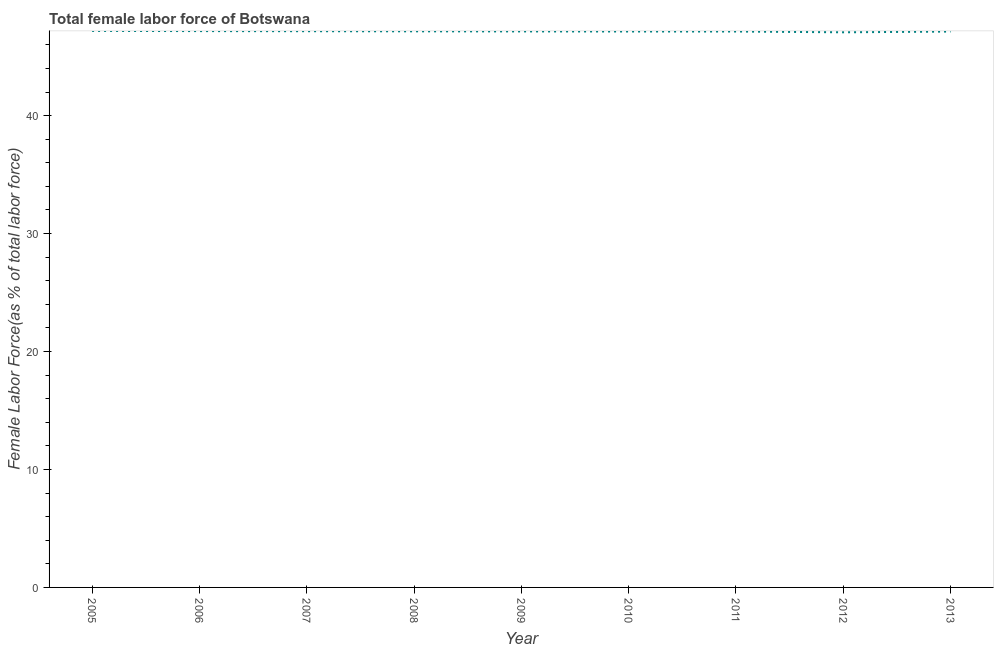What is the total female labor force in 2009?
Offer a very short reply. 47.14. Across all years, what is the maximum total female labor force?
Provide a succinct answer. 47.19. Across all years, what is the minimum total female labor force?
Ensure brevity in your answer.  47.07. In which year was the total female labor force minimum?
Provide a succinct answer. 2012. What is the sum of the total female labor force?
Provide a succinct answer. 424.26. What is the difference between the total female labor force in 2009 and 2013?
Keep it short and to the point. 0.01. What is the average total female labor force per year?
Provide a short and direct response. 47.14. What is the median total female labor force?
Offer a very short reply. 47.14. In how many years, is the total female labor force greater than 8 %?
Your answer should be compact. 9. Do a majority of the years between 2006 and 2011 (inclusive) have total female labor force greater than 22 %?
Provide a short and direct response. Yes. What is the ratio of the total female labor force in 2005 to that in 2012?
Keep it short and to the point. 1. Is the difference between the total female labor force in 2010 and 2013 greater than the difference between any two years?
Ensure brevity in your answer.  No. What is the difference between the highest and the second highest total female labor force?
Ensure brevity in your answer.  0.02. What is the difference between the highest and the lowest total female labor force?
Keep it short and to the point. 0.12. Are the values on the major ticks of Y-axis written in scientific E-notation?
Ensure brevity in your answer.  No. Does the graph contain grids?
Your response must be concise. No. What is the title of the graph?
Provide a succinct answer. Total female labor force of Botswana. What is the label or title of the Y-axis?
Your answer should be compact. Female Labor Force(as % of total labor force). What is the Female Labor Force(as % of total labor force) in 2005?
Ensure brevity in your answer.  47.19. What is the Female Labor Force(as % of total labor force) in 2006?
Offer a very short reply. 47.17. What is the Female Labor Force(as % of total labor force) in 2007?
Offer a terse response. 47.16. What is the Female Labor Force(as % of total labor force) in 2008?
Make the answer very short. 47.15. What is the Female Labor Force(as % of total labor force) in 2009?
Provide a short and direct response. 47.14. What is the Female Labor Force(as % of total labor force) of 2010?
Give a very brief answer. 47.13. What is the Female Labor Force(as % of total labor force) of 2011?
Your response must be concise. 47.13. What is the Female Labor Force(as % of total labor force) of 2012?
Keep it short and to the point. 47.07. What is the Female Labor Force(as % of total labor force) in 2013?
Offer a very short reply. 47.13. What is the difference between the Female Labor Force(as % of total labor force) in 2005 and 2006?
Offer a terse response. 0.02. What is the difference between the Female Labor Force(as % of total labor force) in 2005 and 2007?
Ensure brevity in your answer.  0.03. What is the difference between the Female Labor Force(as % of total labor force) in 2005 and 2008?
Provide a succinct answer. 0.04. What is the difference between the Female Labor Force(as % of total labor force) in 2005 and 2009?
Offer a terse response. 0.04. What is the difference between the Female Labor Force(as % of total labor force) in 2005 and 2010?
Keep it short and to the point. 0.05. What is the difference between the Female Labor Force(as % of total labor force) in 2005 and 2011?
Provide a short and direct response. 0.05. What is the difference between the Female Labor Force(as % of total labor force) in 2005 and 2012?
Your answer should be very brief. 0.12. What is the difference between the Female Labor Force(as % of total labor force) in 2005 and 2013?
Your response must be concise. 0.06. What is the difference between the Female Labor Force(as % of total labor force) in 2006 and 2007?
Provide a short and direct response. 0.01. What is the difference between the Female Labor Force(as % of total labor force) in 2006 and 2008?
Make the answer very short. 0.02. What is the difference between the Female Labor Force(as % of total labor force) in 2006 and 2009?
Offer a terse response. 0.03. What is the difference between the Female Labor Force(as % of total labor force) in 2006 and 2010?
Offer a very short reply. 0.03. What is the difference between the Female Labor Force(as % of total labor force) in 2006 and 2011?
Make the answer very short. 0.04. What is the difference between the Female Labor Force(as % of total labor force) in 2006 and 2012?
Give a very brief answer. 0.1. What is the difference between the Female Labor Force(as % of total labor force) in 2006 and 2013?
Provide a short and direct response. 0.04. What is the difference between the Female Labor Force(as % of total labor force) in 2007 and 2008?
Keep it short and to the point. 0.01. What is the difference between the Female Labor Force(as % of total labor force) in 2007 and 2009?
Ensure brevity in your answer.  0.02. What is the difference between the Female Labor Force(as % of total labor force) in 2007 and 2010?
Give a very brief answer. 0.02. What is the difference between the Female Labor Force(as % of total labor force) in 2007 and 2011?
Keep it short and to the point. 0.03. What is the difference between the Female Labor Force(as % of total labor force) in 2007 and 2012?
Keep it short and to the point. 0.09. What is the difference between the Female Labor Force(as % of total labor force) in 2007 and 2013?
Your response must be concise. 0.03. What is the difference between the Female Labor Force(as % of total labor force) in 2008 and 2009?
Your response must be concise. 0.01. What is the difference between the Female Labor Force(as % of total labor force) in 2008 and 2010?
Your answer should be very brief. 0.01. What is the difference between the Female Labor Force(as % of total labor force) in 2008 and 2011?
Offer a terse response. 0.02. What is the difference between the Female Labor Force(as % of total labor force) in 2008 and 2012?
Offer a terse response. 0.08. What is the difference between the Female Labor Force(as % of total labor force) in 2008 and 2013?
Give a very brief answer. 0.02. What is the difference between the Female Labor Force(as % of total labor force) in 2009 and 2010?
Give a very brief answer. 0.01. What is the difference between the Female Labor Force(as % of total labor force) in 2009 and 2011?
Give a very brief answer. 0.01. What is the difference between the Female Labor Force(as % of total labor force) in 2009 and 2012?
Offer a terse response. 0.07. What is the difference between the Female Labor Force(as % of total labor force) in 2009 and 2013?
Offer a terse response. 0.01. What is the difference between the Female Labor Force(as % of total labor force) in 2010 and 2011?
Your answer should be very brief. 0. What is the difference between the Female Labor Force(as % of total labor force) in 2010 and 2012?
Offer a very short reply. 0.07. What is the difference between the Female Labor Force(as % of total labor force) in 2010 and 2013?
Make the answer very short. 0.01. What is the difference between the Female Labor Force(as % of total labor force) in 2011 and 2012?
Your answer should be compact. 0.07. What is the difference between the Female Labor Force(as % of total labor force) in 2011 and 2013?
Your response must be concise. 0. What is the difference between the Female Labor Force(as % of total labor force) in 2012 and 2013?
Your response must be concise. -0.06. What is the ratio of the Female Labor Force(as % of total labor force) in 2005 to that in 2006?
Offer a terse response. 1. What is the ratio of the Female Labor Force(as % of total labor force) in 2005 to that in 2008?
Provide a succinct answer. 1. What is the ratio of the Female Labor Force(as % of total labor force) in 2005 to that in 2010?
Your answer should be very brief. 1. What is the ratio of the Female Labor Force(as % of total labor force) in 2005 to that in 2013?
Provide a succinct answer. 1. What is the ratio of the Female Labor Force(as % of total labor force) in 2006 to that in 2010?
Offer a terse response. 1. What is the ratio of the Female Labor Force(as % of total labor force) in 2006 to that in 2012?
Your response must be concise. 1. What is the ratio of the Female Labor Force(as % of total labor force) in 2006 to that in 2013?
Offer a terse response. 1. What is the ratio of the Female Labor Force(as % of total labor force) in 2007 to that in 2009?
Offer a terse response. 1. What is the ratio of the Female Labor Force(as % of total labor force) in 2007 to that in 2010?
Make the answer very short. 1. What is the ratio of the Female Labor Force(as % of total labor force) in 2007 to that in 2011?
Your answer should be compact. 1. What is the ratio of the Female Labor Force(as % of total labor force) in 2007 to that in 2013?
Your response must be concise. 1. What is the ratio of the Female Labor Force(as % of total labor force) in 2008 to that in 2009?
Your answer should be very brief. 1. What is the ratio of the Female Labor Force(as % of total labor force) in 2008 to that in 2010?
Give a very brief answer. 1. What is the ratio of the Female Labor Force(as % of total labor force) in 2008 to that in 2011?
Keep it short and to the point. 1. What is the ratio of the Female Labor Force(as % of total labor force) in 2008 to that in 2012?
Offer a very short reply. 1. What is the ratio of the Female Labor Force(as % of total labor force) in 2008 to that in 2013?
Make the answer very short. 1. What is the ratio of the Female Labor Force(as % of total labor force) in 2009 to that in 2012?
Offer a very short reply. 1. What is the ratio of the Female Labor Force(as % of total labor force) in 2010 to that in 2012?
Give a very brief answer. 1. What is the ratio of the Female Labor Force(as % of total labor force) in 2010 to that in 2013?
Ensure brevity in your answer.  1. What is the ratio of the Female Labor Force(as % of total labor force) in 2011 to that in 2013?
Offer a terse response. 1. 